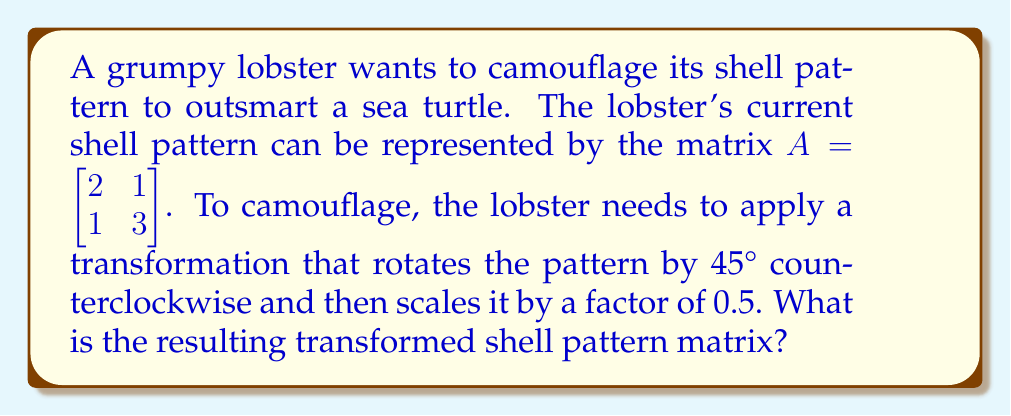Could you help me with this problem? To solve this problem, we need to follow these steps:

1) First, let's recall the rotation matrix for a 45° counterclockwise rotation:

   $R = \begin{bmatrix} \cos 45° & -\sin 45° \\ \sin 45° & \cos 45° \end{bmatrix} = \begin{bmatrix} \frac{\sqrt{2}}{2} & -\frac{\sqrt{2}}{2} \\ \frac{\sqrt{2}}{2} & \frac{\sqrt{2}}{2} \end{bmatrix}$

2) Next, we need to scale by 0.5. The scaling matrix is:

   $S = \begin{bmatrix} 0.5 & 0 \\ 0 & 0.5 \end{bmatrix}$

3) To apply both transformations, we multiply these matrices in the correct order. The order is important: we rotate first, then scale. So our transformation matrix $T$ is:

   $T = SR = \begin{bmatrix} 0.5 & 0 \\ 0 & 0.5 \end{bmatrix} \begin{bmatrix} \frac{\sqrt{2}}{2} & -\frac{\sqrt{2}}{2} \\ \frac{\sqrt{2}}{2} & \frac{\sqrt{2}}{2} \end{bmatrix}$

4) Let's multiply these matrices:

   $T = \begin{bmatrix} 0.5 \cdot \frac{\sqrt{2}}{2} & 0.5 \cdot (-\frac{\sqrt{2}}{2}) \\ 0.5 \cdot \frac{\sqrt{2}}{2} & 0.5 \cdot \frac{\sqrt{2}}{2} \end{bmatrix} = \begin{bmatrix} \frac{\sqrt{2}}{4} & -\frac{\sqrt{2}}{4} \\ \frac{\sqrt{2}}{4} & \frac{\sqrt{2}}{4} \end{bmatrix}$

5) Now, we apply this transformation to the original shell pattern matrix $A$:

   $TA = \begin{bmatrix} \frac{\sqrt{2}}{4} & -\frac{\sqrt{2}}{4} \\ \frac{\sqrt{2}}{4} & \frac{\sqrt{2}}{4} \end{bmatrix} \begin{bmatrix} 2 & 1 \\ 1 & 3 \end{bmatrix}$

6) Multiplying these matrices:

   $TA = \begin{bmatrix} (\frac{\sqrt{2}}{4} \cdot 2 + (-\frac{\sqrt{2}}{4}) \cdot 1) & (\frac{\sqrt{2}}{4} \cdot 1 + (-\frac{\sqrt{2}}{4}) \cdot 3) \\ (\frac{\sqrt{2}}{4} \cdot 2 + \frac{\sqrt{2}}{4} \cdot 1) & (\frac{\sqrt{2}}{4} \cdot 1 + \frac{\sqrt{2}}{4} \cdot 3) \end{bmatrix}$

   $= \begin{bmatrix} \frac{\sqrt{2}}{4} & -\frac{\sqrt{2}}{2} \\ \frac{3\sqrt{2}}{4} & \frac{\sqrt{2}}{2} \end{bmatrix}$

This is the final transformed shell pattern matrix.
Answer: $$\begin{bmatrix} \frac{\sqrt{2}}{4} & -\frac{\sqrt{2}}{2} \\ \frac{3\sqrt{2}}{4} & \frac{\sqrt{2}}{2} \end{bmatrix}$$ 